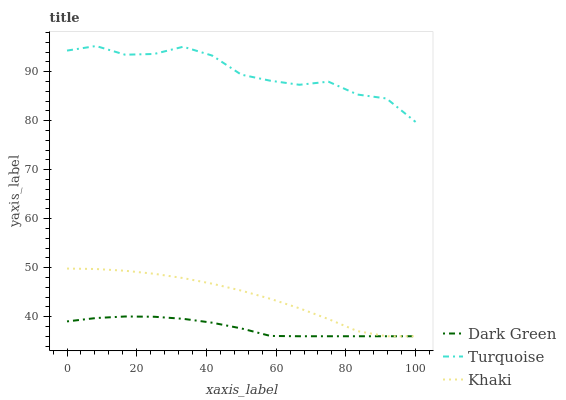Does Dark Green have the minimum area under the curve?
Answer yes or no. Yes. Does Turquoise have the maximum area under the curve?
Answer yes or no. Yes. Does Khaki have the minimum area under the curve?
Answer yes or no. No. Does Khaki have the maximum area under the curve?
Answer yes or no. No. Is Dark Green the smoothest?
Answer yes or no. Yes. Is Turquoise the roughest?
Answer yes or no. Yes. Is Khaki the smoothest?
Answer yes or no. No. Is Khaki the roughest?
Answer yes or no. No. Does Khaki have the lowest value?
Answer yes or no. Yes. Does Turquoise have the highest value?
Answer yes or no. Yes. Does Khaki have the highest value?
Answer yes or no. No. Is Khaki less than Turquoise?
Answer yes or no. Yes. Is Turquoise greater than Khaki?
Answer yes or no. Yes. Does Khaki intersect Dark Green?
Answer yes or no. Yes. Is Khaki less than Dark Green?
Answer yes or no. No. Is Khaki greater than Dark Green?
Answer yes or no. No. Does Khaki intersect Turquoise?
Answer yes or no. No. 